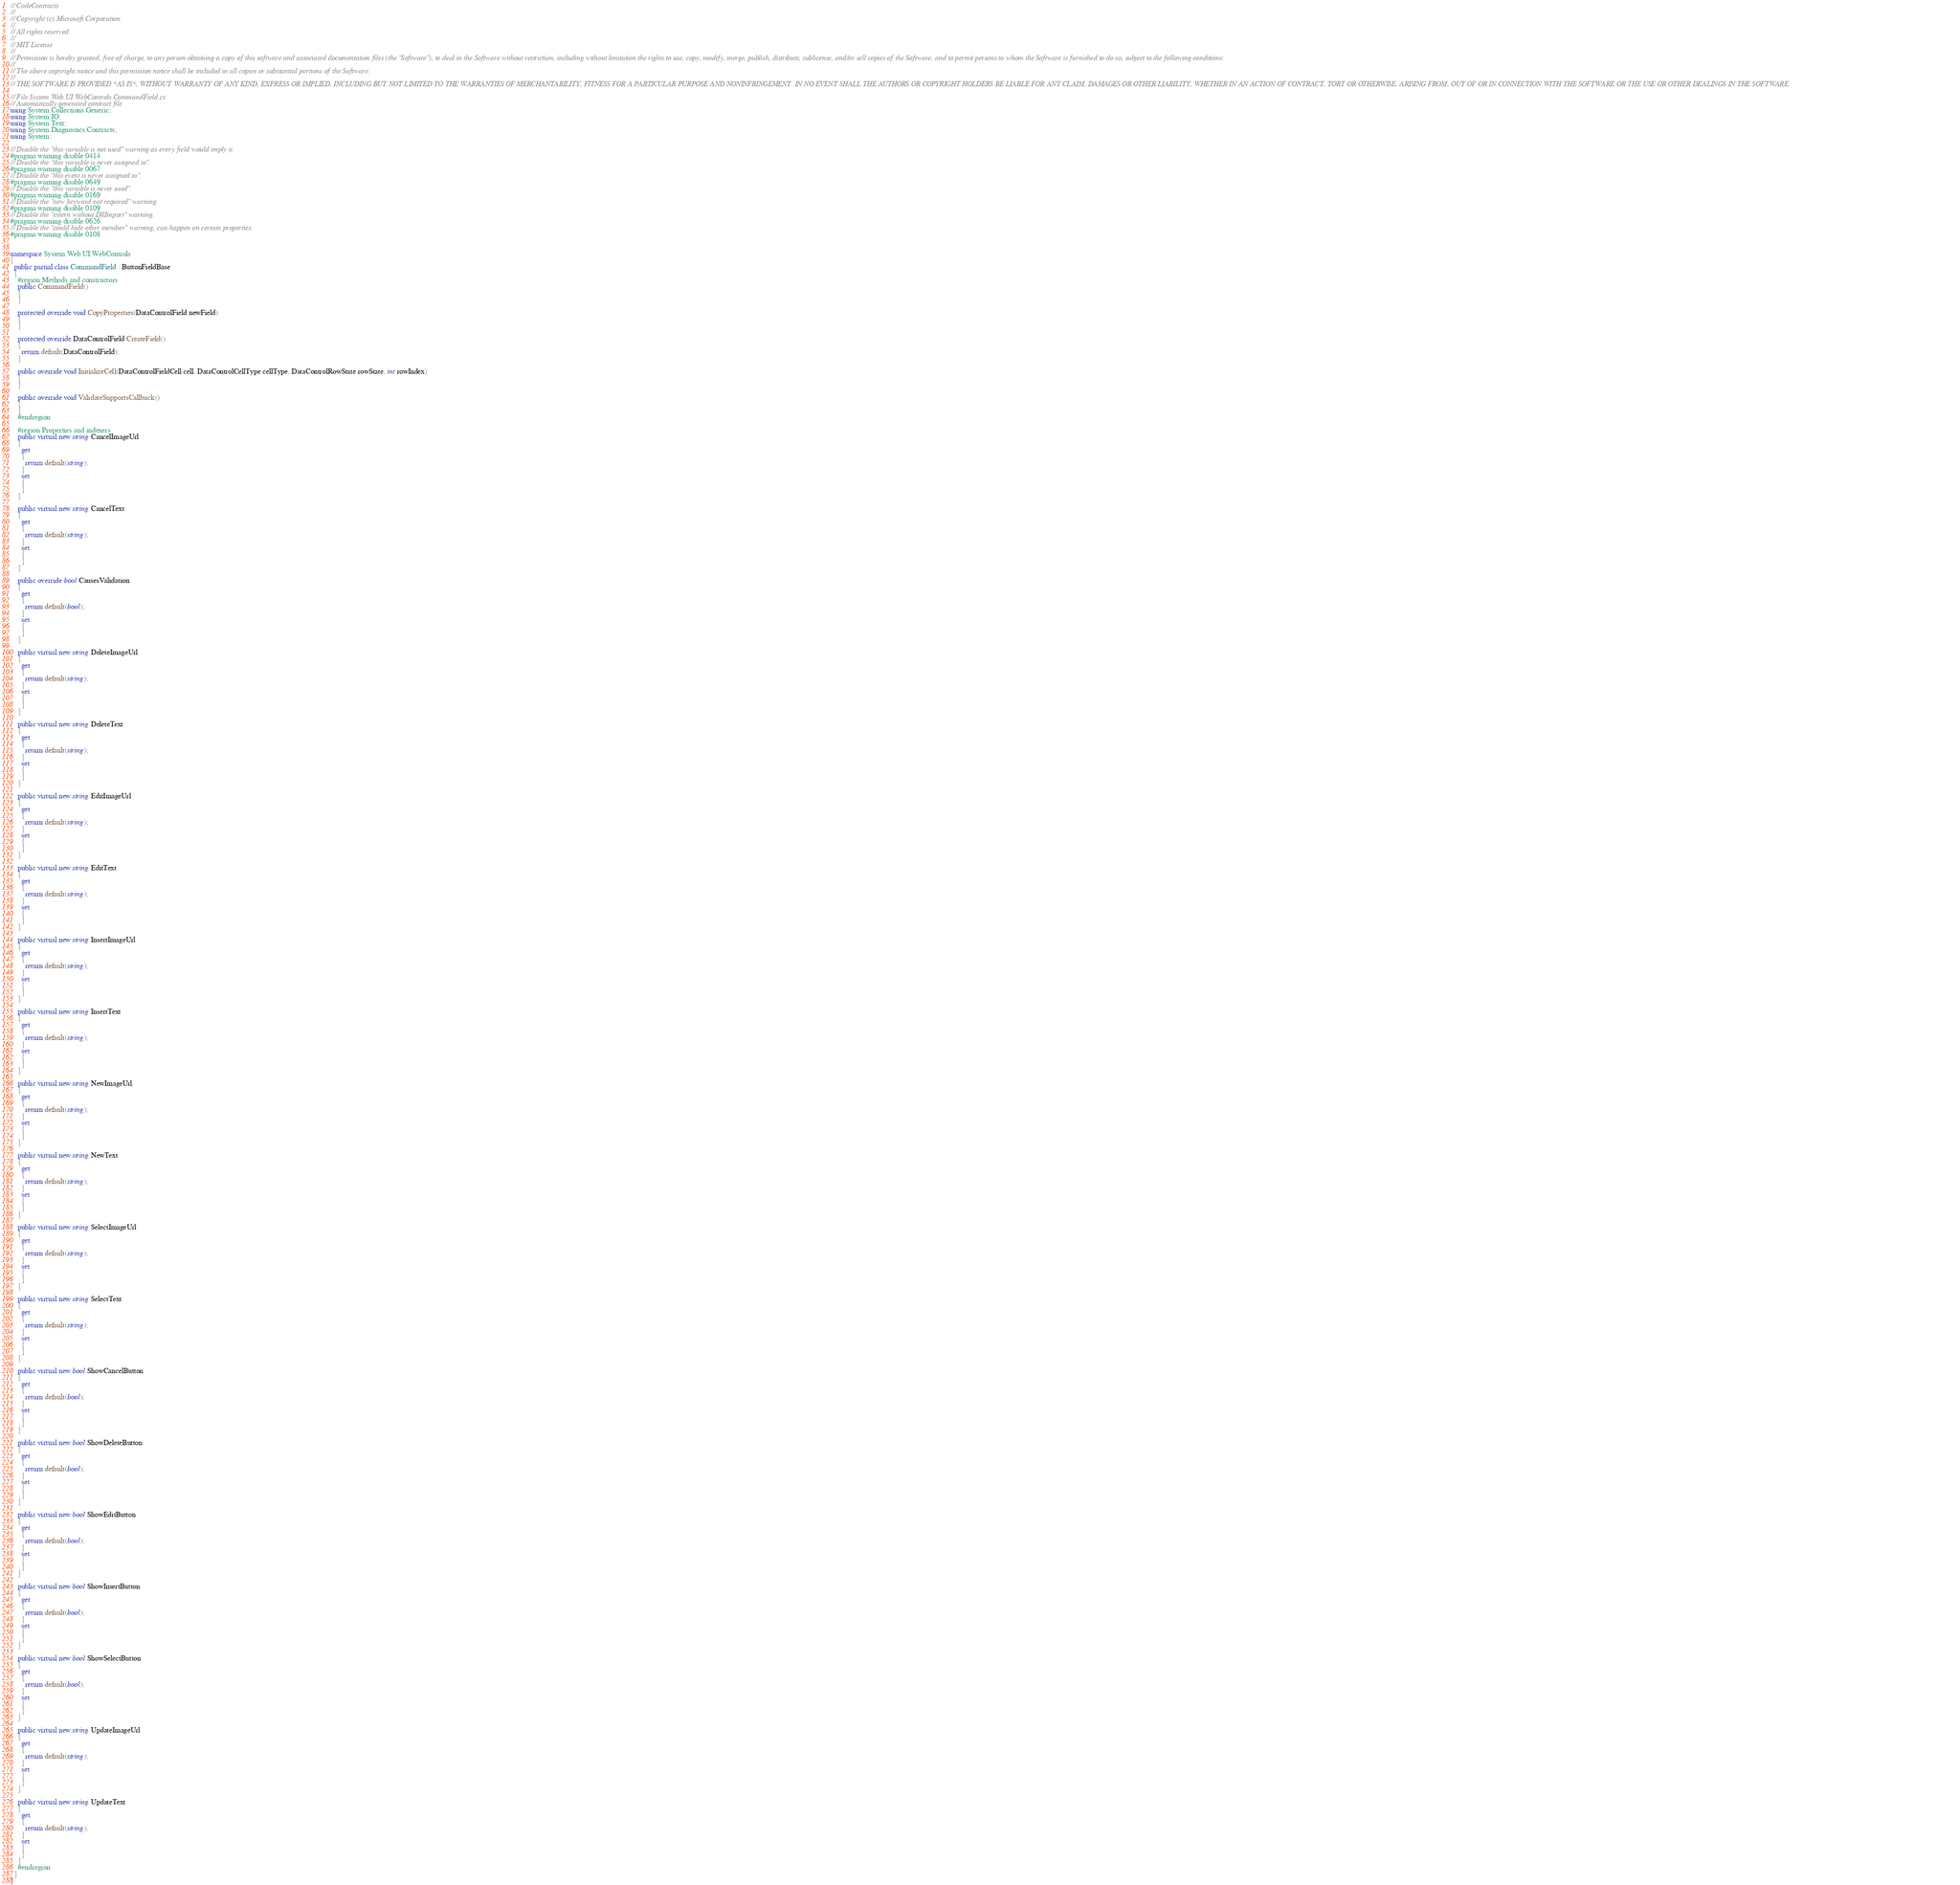Convert code to text. <code><loc_0><loc_0><loc_500><loc_500><_C#_>// CodeContracts
// 
// Copyright (c) Microsoft Corporation
// 
// All rights reserved. 
// 
// MIT License
// 
// Permission is hereby granted, free of charge, to any person obtaining a copy of this software and associated documentation files (the "Software"), to deal in the Software without restriction, including without limitation the rights to use, copy, modify, merge, publish, distribute, sublicense, and/or sell copies of the Software, and to permit persons to whom the Software is furnished to do so, subject to the following conditions:
// 
// The above copyright notice and this permission notice shall be included in all copies or substantial portions of the Software.
// 
// THE SOFTWARE IS PROVIDED *AS IS*, WITHOUT WARRANTY OF ANY KIND, EXPRESS OR IMPLIED, INCLUDING BUT NOT LIMITED TO THE WARRANTIES OF MERCHANTABILITY, FITNESS FOR A PARTICULAR PURPOSE AND NONINFRINGEMENT. IN NO EVENT SHALL THE AUTHORS OR COPYRIGHT HOLDERS BE LIABLE FOR ANY CLAIM, DAMAGES OR OTHER LIABILITY, WHETHER IN AN ACTION OF CONTRACT, TORT OR OTHERWISE, ARISING FROM, OUT OF OR IN CONNECTION WITH THE SOFTWARE OR THE USE OR OTHER DEALINGS IN THE SOFTWARE.

// File System.Web.UI.WebControls.CommandField.cs
// Automatically generated contract file.
using System.Collections.Generic;
using System.IO;
using System.Text;
using System.Diagnostics.Contracts;
using System;

// Disable the "this variable is not used" warning as every field would imply it.
#pragma warning disable 0414
// Disable the "this variable is never assigned to".
#pragma warning disable 0067
// Disable the "this event is never assigned to".
#pragma warning disable 0649
// Disable the "this variable is never used".
#pragma warning disable 0169
// Disable the "new keyword not required" warning.
#pragma warning disable 0109
// Disable the "extern without DllImport" warning.
#pragma warning disable 0626
// Disable the "could hide other member" warning, can happen on certain properties.
#pragma warning disable 0108


namespace System.Web.UI.WebControls
{
  public partial class CommandField : ButtonFieldBase
  {
    #region Methods and constructors
    public CommandField()
    {
    }

    protected override void CopyProperties(DataControlField newField)
    {
    }

    protected override DataControlField CreateField()
    {
      return default(DataControlField);
    }

    public override void InitializeCell(DataControlFieldCell cell, DataControlCellType cellType, DataControlRowState rowState, int rowIndex)
    {
    }

    public override void ValidateSupportsCallback()
    {
    }
    #endregion

    #region Properties and indexers
    public virtual new string CancelImageUrl
    {
      get
      {
        return default(string);
      }
      set
      {
      }
    }

    public virtual new string CancelText
    {
      get
      {
        return default(string);
      }
      set
      {
      }
    }

    public override bool CausesValidation
    {
      get
      {
        return default(bool);
      }
      set
      {
      }
    }

    public virtual new string DeleteImageUrl
    {
      get
      {
        return default(string);
      }
      set
      {
      }
    }

    public virtual new string DeleteText
    {
      get
      {
        return default(string);
      }
      set
      {
      }
    }

    public virtual new string EditImageUrl
    {
      get
      {
        return default(string);
      }
      set
      {
      }
    }

    public virtual new string EditText
    {
      get
      {
        return default(string);
      }
      set
      {
      }
    }

    public virtual new string InsertImageUrl
    {
      get
      {
        return default(string);
      }
      set
      {
      }
    }

    public virtual new string InsertText
    {
      get
      {
        return default(string);
      }
      set
      {
      }
    }

    public virtual new string NewImageUrl
    {
      get
      {
        return default(string);
      }
      set
      {
      }
    }

    public virtual new string NewText
    {
      get
      {
        return default(string);
      }
      set
      {
      }
    }

    public virtual new string SelectImageUrl
    {
      get
      {
        return default(string);
      }
      set
      {
      }
    }

    public virtual new string SelectText
    {
      get
      {
        return default(string);
      }
      set
      {
      }
    }

    public virtual new bool ShowCancelButton
    {
      get
      {
        return default(bool);
      }
      set
      {
      }
    }

    public virtual new bool ShowDeleteButton
    {
      get
      {
        return default(bool);
      }
      set
      {
      }
    }

    public virtual new bool ShowEditButton
    {
      get
      {
        return default(bool);
      }
      set
      {
      }
    }

    public virtual new bool ShowInsertButton
    {
      get
      {
        return default(bool);
      }
      set
      {
      }
    }

    public virtual new bool ShowSelectButton
    {
      get
      {
        return default(bool);
      }
      set
      {
      }
    }

    public virtual new string UpdateImageUrl
    {
      get
      {
        return default(string);
      }
      set
      {
      }
    }

    public virtual new string UpdateText
    {
      get
      {
        return default(string);
      }
      set
      {
      }
    }
    #endregion
  }
}
</code> 